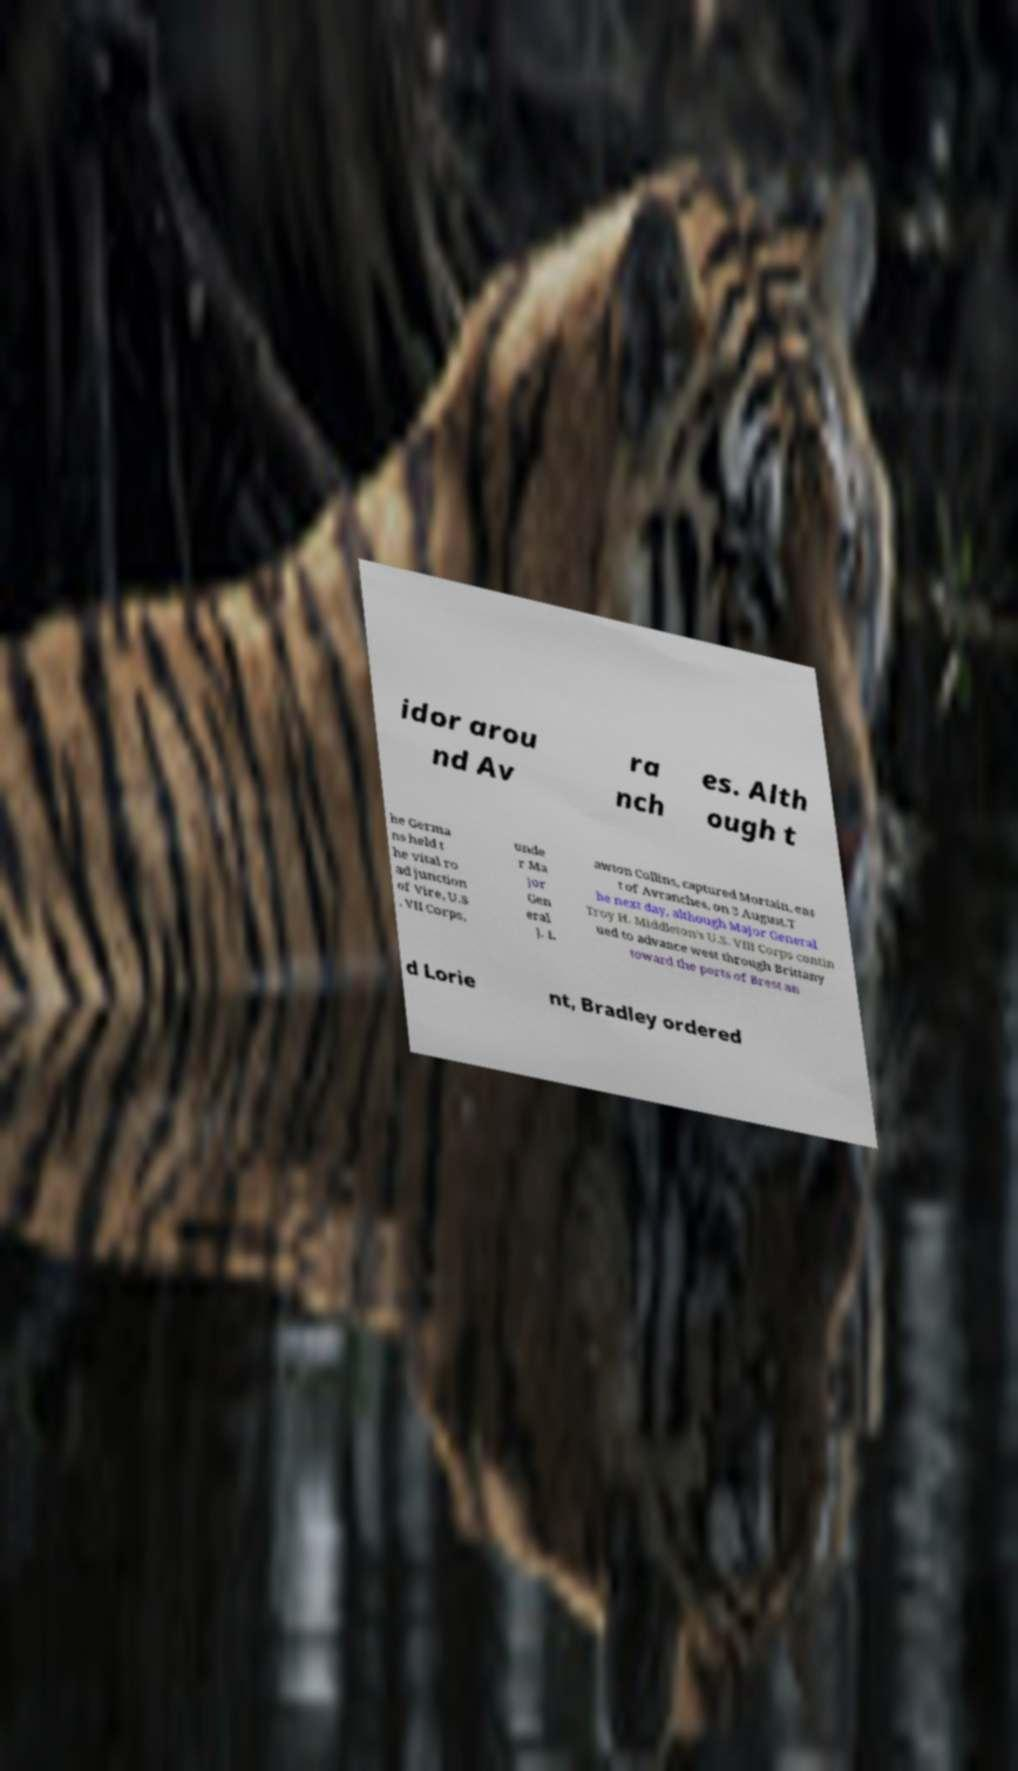Could you extract and type out the text from this image? idor arou nd Av ra nch es. Alth ough t he Germa ns held t he vital ro ad junction of Vire, U.S . VII Corps, unde r Ma jor Gen eral J. L awton Collins, captured Mortain, eas t of Avranches, on 3 August.T he next day, although Major General Troy H. Middleton's U.S. VIII Corps contin ued to advance west through Brittany toward the ports of Brest an d Lorie nt, Bradley ordered 